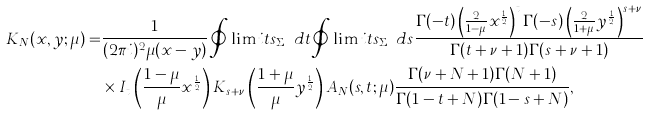<formula> <loc_0><loc_0><loc_500><loc_500>K _ { N } ( x , y ; \mu ) = & \frac { 1 } { ( 2 \pi i ) ^ { 2 } \mu ( x - y ) } \oint \lim i t s _ { \Sigma _ { N } } d t \oint \lim i t s _ { \Sigma _ { N } } d s \frac { \Gamma ( - t ) \left ( \frac { 2 } { 1 - \mu } x ^ { \frac { 1 } { 2 } } \right ) ^ { t } \Gamma ( - s ) \left ( \frac { 2 } { 1 + \mu } y ^ { \frac { 1 } { 2 } } \right ) ^ { s + \nu } } { \Gamma ( t + \nu + 1 ) \Gamma ( s + \nu + 1 ) } \\ & \times I _ { t } \left ( \frac { 1 - \mu } { \mu } x ^ { \frac { 1 } { 2 } } \right ) K _ { s + \nu } \left ( \frac { 1 + \mu } { \mu } y ^ { \frac { 1 } { 2 } } \right ) A _ { N } ( s , t ; \mu ) \frac { \Gamma ( \nu + N + 1 ) \Gamma ( N + 1 ) } { \Gamma ( 1 - t + N ) \Gamma ( 1 - s + N ) } ,</formula> 